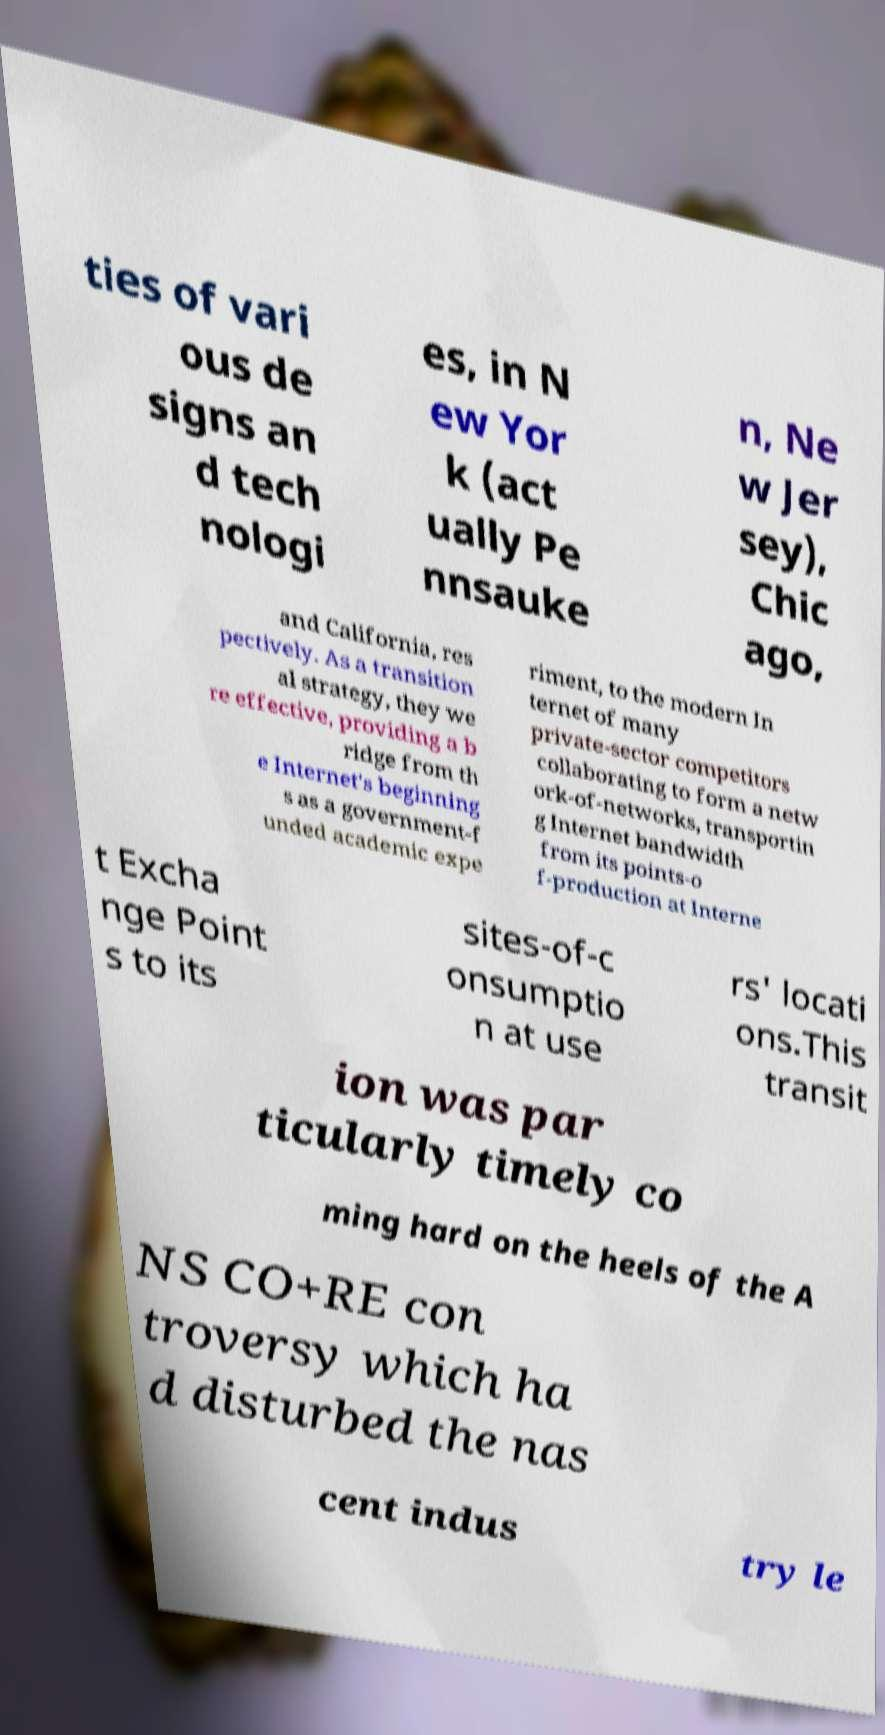What messages or text are displayed in this image? I need them in a readable, typed format. ties of vari ous de signs an d tech nologi es, in N ew Yor k (act ually Pe nnsauke n, Ne w Jer sey), Chic ago, and California, res pectively. As a transition al strategy, they we re effective, providing a b ridge from th e Internet's beginning s as a government-f unded academic expe riment, to the modern In ternet of many private-sector competitors collaborating to form a netw ork-of-networks, transportin g Internet bandwidth from its points-o f-production at Interne t Excha nge Point s to its sites-of-c onsumptio n at use rs' locati ons.This transit ion was par ticularly timely co ming hard on the heels of the A NS CO+RE con troversy which ha d disturbed the nas cent indus try le 